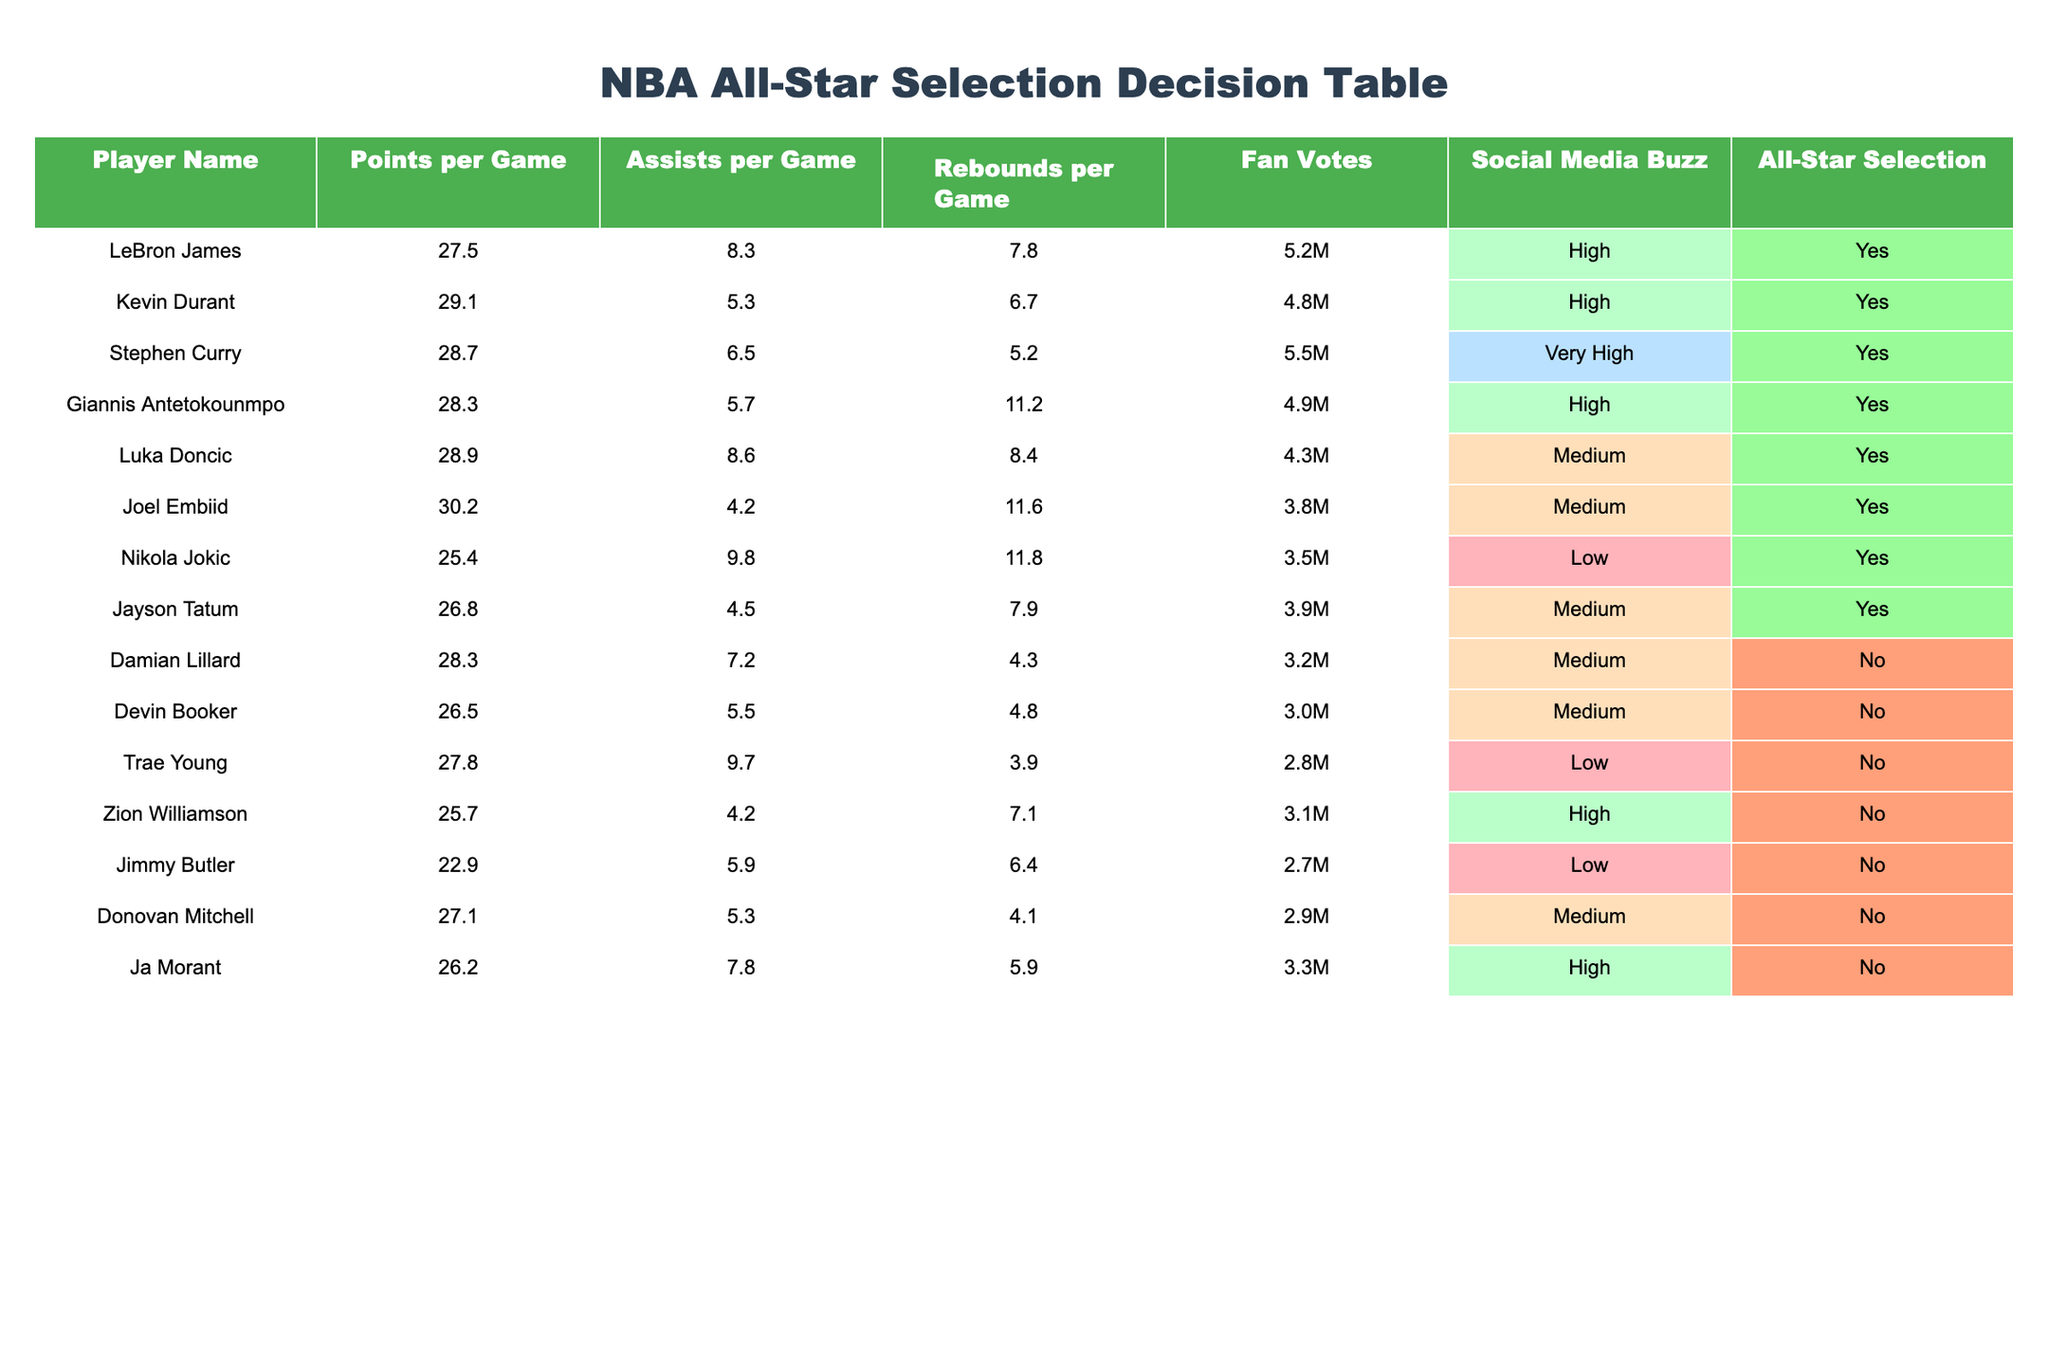What is the points per game average for Joel Embiid? Referring to the table, the data indicates that Joel Embiid has a points per game average of 30.2.
Answer: 30.2 How many fan votes did LeBron James receive? The table shows that LeBron James received 5.2 million fan votes, as represented in the column 'Fan Votes'.
Answer: 5.2M Which player has the highest number of assists per game? By inspecting the 'Assists per Game' column, Stephen Curry stands out with an average of 6.5 assists, the highest compared to other players listed.
Answer: 6.5 Is Damian Lillard an All-Star selection according to the data? The table indicates that Damian Lillard has the 'All-Star Selection' status as 'No'.
Answer: No What is the average number of rebounds for the players who were selected as All-Stars? First, identify the players with 'Yes' in the 'All-Star Selection' column: LeBron James, Kevin Durant, Stephen Curry, Giannis Antetokounmpo, Luka Doncic, Joel Embiid, Nikola Jokic, Jayson Tatum. Their rebounds per game numbers are: 7.8, 6.7, 5.2, 11.2, 8.4, 11.6, 11.8, 7.9. The sum is 70.8, and there are 8 players, so the average is 70.8/8 = 8.85.
Answer: 8.85 Which player has the lowest social media buzz but still made the All-Star selection? Observing the 'Social Media Buzz' column, Nikola Jokic has a 'Low' buzz rating but is marked as an 'All-Star Selection' with a 'Yes'.
Answer: Nikola Jokic How many players in the table are selected as All-Stars with medium social media buzz? The players that have 'Medium' listed in their social media buzz are Luka Doncic, Joel Embiid, and Jayson Tatum, all of which are selected as All-Stars. There are 3 such players.
Answer: 3 What is the sum of points per game for all players selected as All-Stars? From the All-Star selections, we need the points per game of: LeBron James (27.5), Kevin Durant (29.1), Stephen Curry (28.7), Giannis Antetokounmpo (28.3), Luka Doncic (28.9), Joel Embiid (30.2), Nikola Jokic (25.4), and Jayson Tatum (26.8). Summing these values gives 27.5 + 29.1 + 28.7 + 28.3 + 28.9 + 30.2 + 25.4 + 26.8 = 229.9.
Answer: 229.9 How many rebounds per game does Zion Williamson have? Checking the 'Rebounds per Game' column, Zion Williamson has 7.1 rebounds per game listed.
Answer: 7.1 